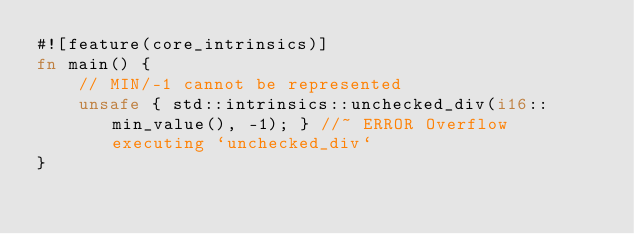<code> <loc_0><loc_0><loc_500><loc_500><_Rust_>#![feature(core_intrinsics)]
fn main() {
    // MIN/-1 cannot be represented
    unsafe { std::intrinsics::unchecked_div(i16::min_value(), -1); } //~ ERROR Overflow executing `unchecked_div`
}
</code> 